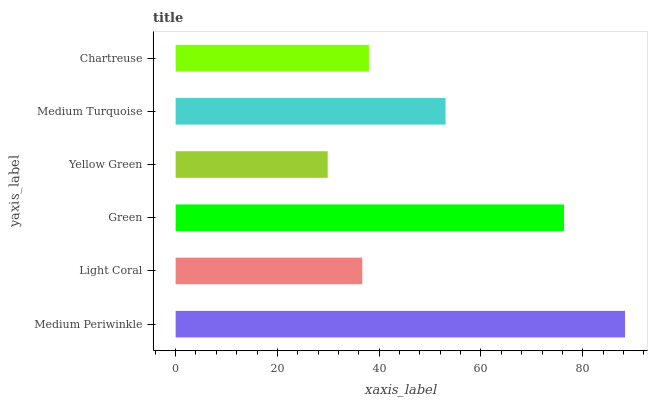Is Yellow Green the minimum?
Answer yes or no. Yes. Is Medium Periwinkle the maximum?
Answer yes or no. Yes. Is Light Coral the minimum?
Answer yes or no. No. Is Light Coral the maximum?
Answer yes or no. No. Is Medium Periwinkle greater than Light Coral?
Answer yes or no. Yes. Is Light Coral less than Medium Periwinkle?
Answer yes or no. Yes. Is Light Coral greater than Medium Periwinkle?
Answer yes or no. No. Is Medium Periwinkle less than Light Coral?
Answer yes or no. No. Is Medium Turquoise the high median?
Answer yes or no. Yes. Is Chartreuse the low median?
Answer yes or no. Yes. Is Chartreuse the high median?
Answer yes or no. No. Is Green the low median?
Answer yes or no. No. 